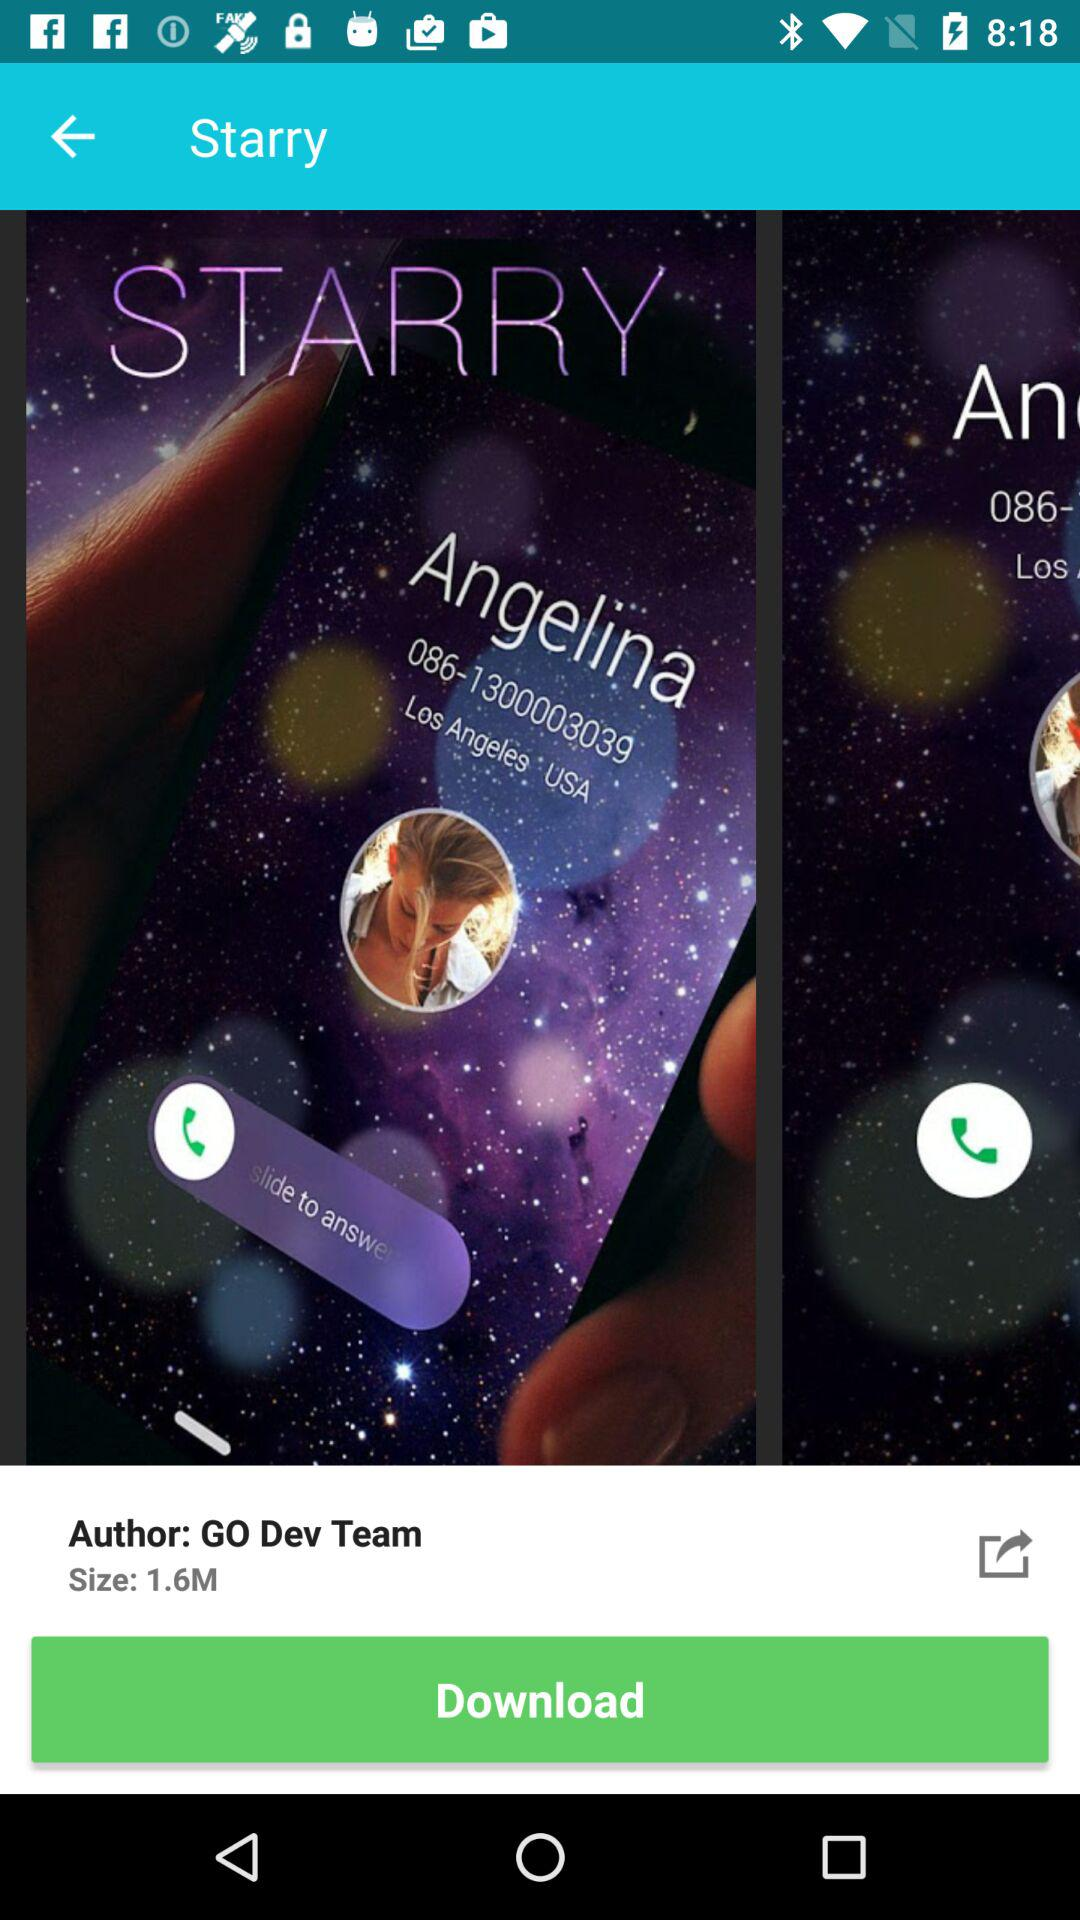What is the size of the "Starry"? The size of the "Starry" is 1.6M. 